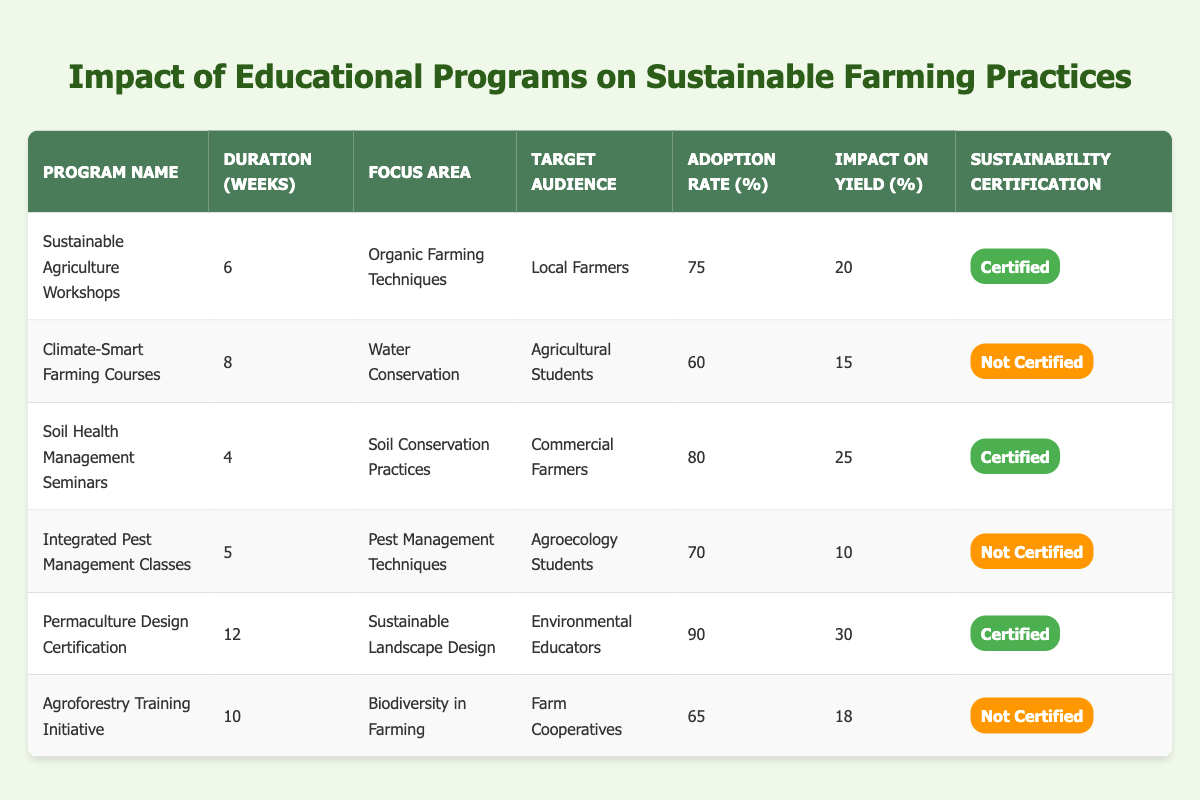What is the duration of the "Soil Health Management Seminars"? The duration of the "Soil Health Management Seminars" can be found directly in the table under the Duration (Weeks) column. It shows that the duration is 4 weeks.
Answer: 4 weeks Which program has the highest adoption rate? To determine which program has the highest adoption rate, we can look at the Adoption Rate (%) column and identify the maximum value. The "Permaculture Design Certification" has the highest adoption rate at 90%.
Answer: 90% Is the "Climate-Smart Farming Courses" program certified? The certification status of the "Climate-Smart Farming Courses" can be found in the Sustainability Certification column. It indicates that this program is marked as "Not Certified".
Answer: Not Certified What is the impact on yield of the "Integrated Pest Management Classes"? The impact on yield can be found in the Impact on Yield (%) column corresponding to the "Integrated Pest Management Classes", which shows an impact of 10%.
Answer: 10% What is the average impact on yield for all programs that are certified? To calculate the average impact on yield for certified programs, we first identify that three programs have certification: "Sustainable Agriculture Workshops" (20%), "Soil Health Management Seminars" (25%), and "Permaculture Design Certification" (30%). Summing these yields gives us 20 + 25 + 30 = 75. We then divide by the number of certified programs, which is 3: 75/3 = 25.
Answer: 25 Which target audience has the program with the longest duration? To find the target audience with the longest program duration, we need to look at the Duration (Weeks) column. The program with the longest duration is "Permaculture Design Certification" at 12 weeks, which targets "Environmental Educators".
Answer: Environmental Educators How many programs have an impact on yield greater than 20%? We check the Impact on Yield (%) column for programs exceeding 20%. The programs "Soil Health Management Seminars" (25%) and "Permaculture Design Certification" (30%) meet this criterion. Therefore, there are 2 programs with an impact on yield greater than 20%.
Answer: 2 Are there more programs targeting local farmers or agricultural students? To answer this, we look at the Target Audience column and count the relevant programs. There is 1 program targeting local farmers ("Sustainable Agriculture Workshops") and 1 program targeting agricultural students ("Climate-Smart Farming Courses"). Thus, there is an equal number of programs for both audiences.
Answer: Equal What is the total adoption rate of all programs? To find the total adoption rate, we need to sum all values in the Adoption Rate (%) column, which are 75, 60, 80, 70, 90, and 65. Adding these, 75 + 60 + 80 + 70 + 90 + 65 = 440.
Answer: 440 